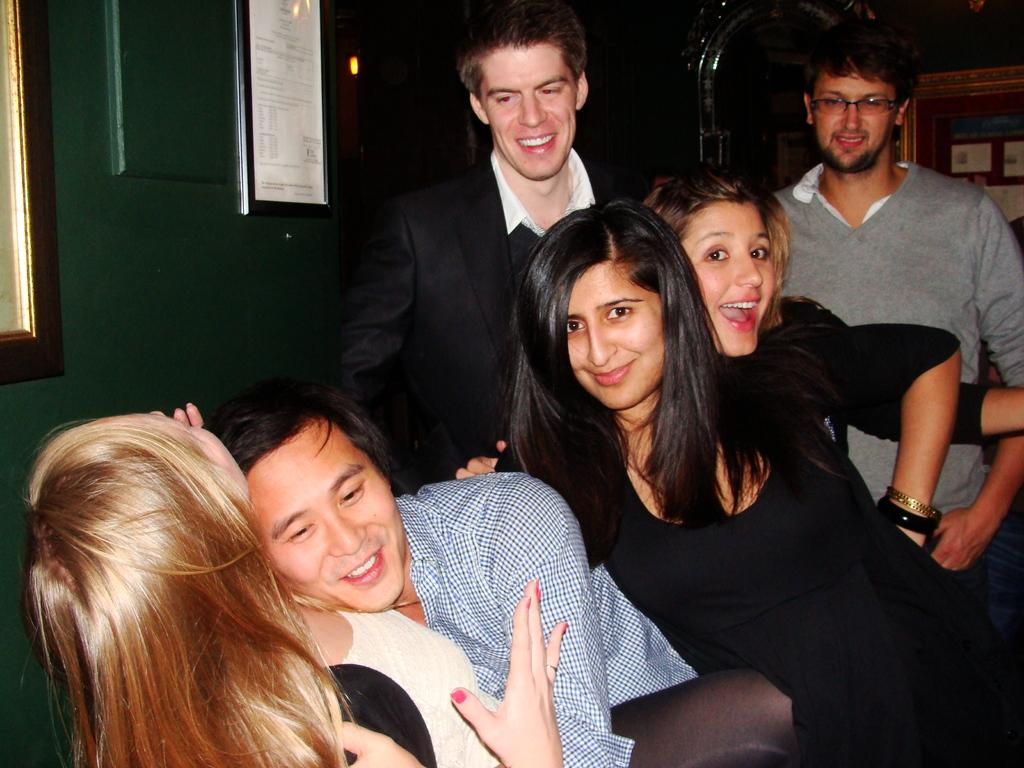How many people are in the image? There are people in the image, but the exact number is not specified. What can be observed about the people's clothing? The people are wearing different color dresses. What color is the wall in the image? There is a green wall in the image. What is attached to the green wall? A frame is attached to the green wall. What can be seen at the back of the image? There are objects visible at the back of the image. What type of tin can be seen in the image? There is no tin present in the image. What year is depicted in the image? The year is not depicted in the image; it is a scene with people, a green wall, a frame, and objects in the background. 